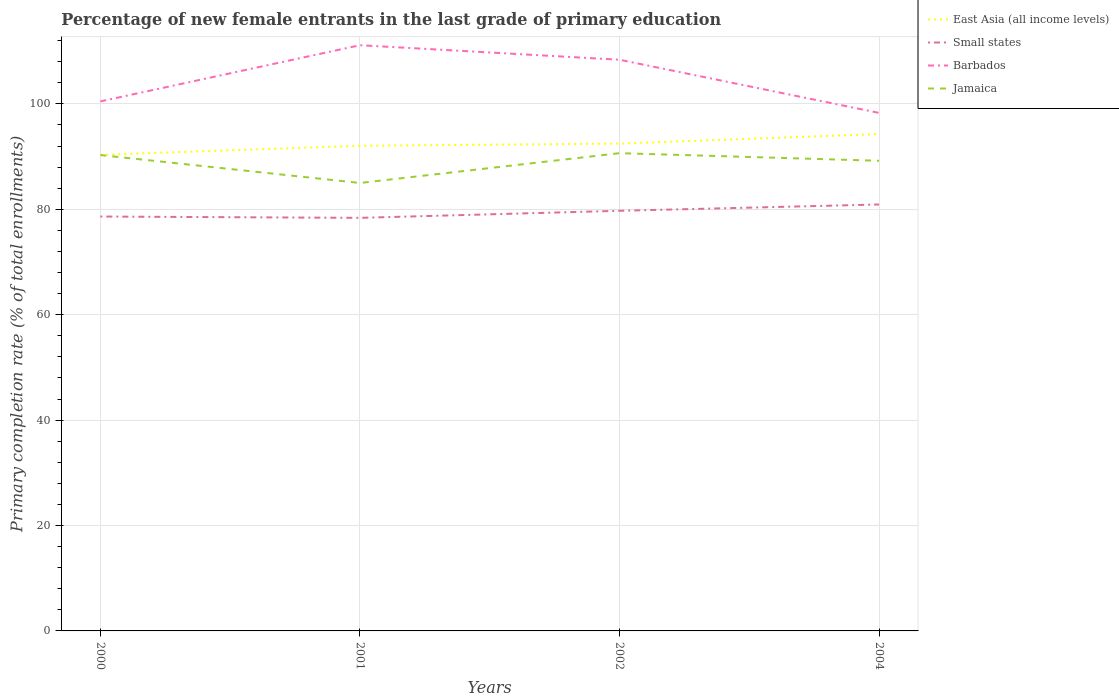How many different coloured lines are there?
Offer a very short reply. 4. Across all years, what is the maximum percentage of new female entrants in Jamaica?
Make the answer very short. 84.99. In which year was the percentage of new female entrants in Jamaica maximum?
Give a very brief answer. 2001. What is the total percentage of new female entrants in Jamaica in the graph?
Provide a short and direct response. -4.21. What is the difference between the highest and the second highest percentage of new female entrants in East Asia (all income levels)?
Give a very brief answer. 3.93. What is the difference between the highest and the lowest percentage of new female entrants in East Asia (all income levels)?
Ensure brevity in your answer.  2. What is the difference between two consecutive major ticks on the Y-axis?
Keep it short and to the point. 20. Are the values on the major ticks of Y-axis written in scientific E-notation?
Ensure brevity in your answer.  No. Does the graph contain any zero values?
Offer a terse response. No. Where does the legend appear in the graph?
Your answer should be compact. Top right. How are the legend labels stacked?
Your answer should be very brief. Vertical. What is the title of the graph?
Make the answer very short. Percentage of new female entrants in the last grade of primary education. What is the label or title of the Y-axis?
Ensure brevity in your answer.  Primary completion rate (% of total enrollments). What is the Primary completion rate (% of total enrollments) in East Asia (all income levels) in 2000?
Offer a terse response. 90.35. What is the Primary completion rate (% of total enrollments) in Small states in 2000?
Give a very brief answer. 78.63. What is the Primary completion rate (% of total enrollments) in Barbados in 2000?
Your response must be concise. 100.47. What is the Primary completion rate (% of total enrollments) of Jamaica in 2000?
Offer a very short reply. 90.29. What is the Primary completion rate (% of total enrollments) of East Asia (all income levels) in 2001?
Your answer should be very brief. 92.05. What is the Primary completion rate (% of total enrollments) of Small states in 2001?
Provide a short and direct response. 78.38. What is the Primary completion rate (% of total enrollments) in Barbados in 2001?
Your answer should be compact. 111.13. What is the Primary completion rate (% of total enrollments) in Jamaica in 2001?
Your answer should be compact. 84.99. What is the Primary completion rate (% of total enrollments) of East Asia (all income levels) in 2002?
Keep it short and to the point. 92.46. What is the Primary completion rate (% of total enrollments) of Small states in 2002?
Ensure brevity in your answer.  79.72. What is the Primary completion rate (% of total enrollments) of Barbados in 2002?
Make the answer very short. 108.38. What is the Primary completion rate (% of total enrollments) in Jamaica in 2002?
Your response must be concise. 90.65. What is the Primary completion rate (% of total enrollments) in East Asia (all income levels) in 2004?
Offer a very short reply. 94.28. What is the Primary completion rate (% of total enrollments) in Small states in 2004?
Keep it short and to the point. 80.91. What is the Primary completion rate (% of total enrollments) in Barbados in 2004?
Give a very brief answer. 98.29. What is the Primary completion rate (% of total enrollments) in Jamaica in 2004?
Provide a succinct answer. 89.21. Across all years, what is the maximum Primary completion rate (% of total enrollments) in East Asia (all income levels)?
Your answer should be compact. 94.28. Across all years, what is the maximum Primary completion rate (% of total enrollments) in Small states?
Give a very brief answer. 80.91. Across all years, what is the maximum Primary completion rate (% of total enrollments) in Barbados?
Your response must be concise. 111.13. Across all years, what is the maximum Primary completion rate (% of total enrollments) of Jamaica?
Your response must be concise. 90.65. Across all years, what is the minimum Primary completion rate (% of total enrollments) of East Asia (all income levels)?
Ensure brevity in your answer.  90.35. Across all years, what is the minimum Primary completion rate (% of total enrollments) of Small states?
Offer a very short reply. 78.38. Across all years, what is the minimum Primary completion rate (% of total enrollments) in Barbados?
Make the answer very short. 98.29. Across all years, what is the minimum Primary completion rate (% of total enrollments) in Jamaica?
Ensure brevity in your answer.  84.99. What is the total Primary completion rate (% of total enrollments) of East Asia (all income levels) in the graph?
Your response must be concise. 369.14. What is the total Primary completion rate (% of total enrollments) of Small states in the graph?
Provide a short and direct response. 317.63. What is the total Primary completion rate (% of total enrollments) of Barbados in the graph?
Offer a terse response. 418.27. What is the total Primary completion rate (% of total enrollments) of Jamaica in the graph?
Your answer should be compact. 355.14. What is the difference between the Primary completion rate (% of total enrollments) in East Asia (all income levels) in 2000 and that in 2001?
Your answer should be very brief. -1.71. What is the difference between the Primary completion rate (% of total enrollments) in Small states in 2000 and that in 2001?
Give a very brief answer. 0.25. What is the difference between the Primary completion rate (% of total enrollments) in Barbados in 2000 and that in 2001?
Your answer should be compact. -10.66. What is the difference between the Primary completion rate (% of total enrollments) of Jamaica in 2000 and that in 2001?
Your response must be concise. 5.3. What is the difference between the Primary completion rate (% of total enrollments) in East Asia (all income levels) in 2000 and that in 2002?
Your answer should be compact. -2.11. What is the difference between the Primary completion rate (% of total enrollments) in Small states in 2000 and that in 2002?
Offer a terse response. -1.09. What is the difference between the Primary completion rate (% of total enrollments) of Barbados in 2000 and that in 2002?
Your response must be concise. -7.91. What is the difference between the Primary completion rate (% of total enrollments) in Jamaica in 2000 and that in 2002?
Your answer should be very brief. -0.36. What is the difference between the Primary completion rate (% of total enrollments) of East Asia (all income levels) in 2000 and that in 2004?
Your answer should be compact. -3.93. What is the difference between the Primary completion rate (% of total enrollments) of Small states in 2000 and that in 2004?
Offer a very short reply. -2.28. What is the difference between the Primary completion rate (% of total enrollments) in Barbados in 2000 and that in 2004?
Offer a terse response. 2.18. What is the difference between the Primary completion rate (% of total enrollments) of Jamaica in 2000 and that in 2004?
Offer a very short reply. 1.09. What is the difference between the Primary completion rate (% of total enrollments) of East Asia (all income levels) in 2001 and that in 2002?
Make the answer very short. -0.41. What is the difference between the Primary completion rate (% of total enrollments) in Small states in 2001 and that in 2002?
Offer a very short reply. -1.34. What is the difference between the Primary completion rate (% of total enrollments) in Barbados in 2001 and that in 2002?
Provide a succinct answer. 2.76. What is the difference between the Primary completion rate (% of total enrollments) of Jamaica in 2001 and that in 2002?
Give a very brief answer. -5.65. What is the difference between the Primary completion rate (% of total enrollments) in East Asia (all income levels) in 2001 and that in 2004?
Provide a short and direct response. -2.23. What is the difference between the Primary completion rate (% of total enrollments) in Small states in 2001 and that in 2004?
Your response must be concise. -2.54. What is the difference between the Primary completion rate (% of total enrollments) of Barbados in 2001 and that in 2004?
Your response must be concise. 12.85. What is the difference between the Primary completion rate (% of total enrollments) of Jamaica in 2001 and that in 2004?
Your response must be concise. -4.21. What is the difference between the Primary completion rate (% of total enrollments) in East Asia (all income levels) in 2002 and that in 2004?
Your response must be concise. -1.82. What is the difference between the Primary completion rate (% of total enrollments) of Small states in 2002 and that in 2004?
Your answer should be compact. -1.19. What is the difference between the Primary completion rate (% of total enrollments) of Barbados in 2002 and that in 2004?
Your response must be concise. 10.09. What is the difference between the Primary completion rate (% of total enrollments) of Jamaica in 2002 and that in 2004?
Provide a short and direct response. 1.44. What is the difference between the Primary completion rate (% of total enrollments) of East Asia (all income levels) in 2000 and the Primary completion rate (% of total enrollments) of Small states in 2001?
Offer a terse response. 11.97. What is the difference between the Primary completion rate (% of total enrollments) of East Asia (all income levels) in 2000 and the Primary completion rate (% of total enrollments) of Barbados in 2001?
Ensure brevity in your answer.  -20.79. What is the difference between the Primary completion rate (% of total enrollments) in East Asia (all income levels) in 2000 and the Primary completion rate (% of total enrollments) in Jamaica in 2001?
Offer a terse response. 5.35. What is the difference between the Primary completion rate (% of total enrollments) in Small states in 2000 and the Primary completion rate (% of total enrollments) in Barbados in 2001?
Your response must be concise. -32.51. What is the difference between the Primary completion rate (% of total enrollments) of Small states in 2000 and the Primary completion rate (% of total enrollments) of Jamaica in 2001?
Offer a terse response. -6.37. What is the difference between the Primary completion rate (% of total enrollments) in Barbados in 2000 and the Primary completion rate (% of total enrollments) in Jamaica in 2001?
Your answer should be compact. 15.48. What is the difference between the Primary completion rate (% of total enrollments) in East Asia (all income levels) in 2000 and the Primary completion rate (% of total enrollments) in Small states in 2002?
Provide a short and direct response. 10.63. What is the difference between the Primary completion rate (% of total enrollments) of East Asia (all income levels) in 2000 and the Primary completion rate (% of total enrollments) of Barbados in 2002?
Your response must be concise. -18.03. What is the difference between the Primary completion rate (% of total enrollments) of East Asia (all income levels) in 2000 and the Primary completion rate (% of total enrollments) of Jamaica in 2002?
Make the answer very short. -0.3. What is the difference between the Primary completion rate (% of total enrollments) of Small states in 2000 and the Primary completion rate (% of total enrollments) of Barbados in 2002?
Keep it short and to the point. -29.75. What is the difference between the Primary completion rate (% of total enrollments) of Small states in 2000 and the Primary completion rate (% of total enrollments) of Jamaica in 2002?
Make the answer very short. -12.02. What is the difference between the Primary completion rate (% of total enrollments) in Barbados in 2000 and the Primary completion rate (% of total enrollments) in Jamaica in 2002?
Offer a very short reply. 9.82. What is the difference between the Primary completion rate (% of total enrollments) of East Asia (all income levels) in 2000 and the Primary completion rate (% of total enrollments) of Small states in 2004?
Offer a very short reply. 9.44. What is the difference between the Primary completion rate (% of total enrollments) in East Asia (all income levels) in 2000 and the Primary completion rate (% of total enrollments) in Barbados in 2004?
Provide a short and direct response. -7.94. What is the difference between the Primary completion rate (% of total enrollments) in East Asia (all income levels) in 2000 and the Primary completion rate (% of total enrollments) in Jamaica in 2004?
Give a very brief answer. 1.14. What is the difference between the Primary completion rate (% of total enrollments) of Small states in 2000 and the Primary completion rate (% of total enrollments) of Barbados in 2004?
Offer a very short reply. -19.66. What is the difference between the Primary completion rate (% of total enrollments) of Small states in 2000 and the Primary completion rate (% of total enrollments) of Jamaica in 2004?
Provide a succinct answer. -10.58. What is the difference between the Primary completion rate (% of total enrollments) in Barbados in 2000 and the Primary completion rate (% of total enrollments) in Jamaica in 2004?
Keep it short and to the point. 11.26. What is the difference between the Primary completion rate (% of total enrollments) in East Asia (all income levels) in 2001 and the Primary completion rate (% of total enrollments) in Small states in 2002?
Make the answer very short. 12.34. What is the difference between the Primary completion rate (% of total enrollments) of East Asia (all income levels) in 2001 and the Primary completion rate (% of total enrollments) of Barbados in 2002?
Make the answer very short. -16.32. What is the difference between the Primary completion rate (% of total enrollments) in East Asia (all income levels) in 2001 and the Primary completion rate (% of total enrollments) in Jamaica in 2002?
Your answer should be very brief. 1.4. What is the difference between the Primary completion rate (% of total enrollments) in Small states in 2001 and the Primary completion rate (% of total enrollments) in Barbados in 2002?
Your response must be concise. -30. What is the difference between the Primary completion rate (% of total enrollments) in Small states in 2001 and the Primary completion rate (% of total enrollments) in Jamaica in 2002?
Keep it short and to the point. -12.27. What is the difference between the Primary completion rate (% of total enrollments) in Barbados in 2001 and the Primary completion rate (% of total enrollments) in Jamaica in 2002?
Make the answer very short. 20.49. What is the difference between the Primary completion rate (% of total enrollments) of East Asia (all income levels) in 2001 and the Primary completion rate (% of total enrollments) of Small states in 2004?
Provide a succinct answer. 11.14. What is the difference between the Primary completion rate (% of total enrollments) in East Asia (all income levels) in 2001 and the Primary completion rate (% of total enrollments) in Barbados in 2004?
Offer a terse response. -6.24. What is the difference between the Primary completion rate (% of total enrollments) in East Asia (all income levels) in 2001 and the Primary completion rate (% of total enrollments) in Jamaica in 2004?
Give a very brief answer. 2.85. What is the difference between the Primary completion rate (% of total enrollments) of Small states in 2001 and the Primary completion rate (% of total enrollments) of Barbados in 2004?
Keep it short and to the point. -19.91. What is the difference between the Primary completion rate (% of total enrollments) of Small states in 2001 and the Primary completion rate (% of total enrollments) of Jamaica in 2004?
Offer a terse response. -10.83. What is the difference between the Primary completion rate (% of total enrollments) of Barbados in 2001 and the Primary completion rate (% of total enrollments) of Jamaica in 2004?
Your response must be concise. 21.93. What is the difference between the Primary completion rate (% of total enrollments) of East Asia (all income levels) in 2002 and the Primary completion rate (% of total enrollments) of Small states in 2004?
Provide a succinct answer. 11.55. What is the difference between the Primary completion rate (% of total enrollments) in East Asia (all income levels) in 2002 and the Primary completion rate (% of total enrollments) in Barbados in 2004?
Provide a succinct answer. -5.83. What is the difference between the Primary completion rate (% of total enrollments) in East Asia (all income levels) in 2002 and the Primary completion rate (% of total enrollments) in Jamaica in 2004?
Your answer should be very brief. 3.26. What is the difference between the Primary completion rate (% of total enrollments) of Small states in 2002 and the Primary completion rate (% of total enrollments) of Barbados in 2004?
Keep it short and to the point. -18.57. What is the difference between the Primary completion rate (% of total enrollments) of Small states in 2002 and the Primary completion rate (% of total enrollments) of Jamaica in 2004?
Provide a succinct answer. -9.49. What is the difference between the Primary completion rate (% of total enrollments) of Barbados in 2002 and the Primary completion rate (% of total enrollments) of Jamaica in 2004?
Provide a succinct answer. 19.17. What is the average Primary completion rate (% of total enrollments) of East Asia (all income levels) per year?
Ensure brevity in your answer.  92.29. What is the average Primary completion rate (% of total enrollments) of Small states per year?
Provide a succinct answer. 79.41. What is the average Primary completion rate (% of total enrollments) in Barbados per year?
Give a very brief answer. 104.57. What is the average Primary completion rate (% of total enrollments) in Jamaica per year?
Ensure brevity in your answer.  88.79. In the year 2000, what is the difference between the Primary completion rate (% of total enrollments) of East Asia (all income levels) and Primary completion rate (% of total enrollments) of Small states?
Your response must be concise. 11.72. In the year 2000, what is the difference between the Primary completion rate (% of total enrollments) in East Asia (all income levels) and Primary completion rate (% of total enrollments) in Barbados?
Offer a terse response. -10.12. In the year 2000, what is the difference between the Primary completion rate (% of total enrollments) of East Asia (all income levels) and Primary completion rate (% of total enrollments) of Jamaica?
Provide a succinct answer. 0.05. In the year 2000, what is the difference between the Primary completion rate (% of total enrollments) of Small states and Primary completion rate (% of total enrollments) of Barbados?
Provide a short and direct response. -21.84. In the year 2000, what is the difference between the Primary completion rate (% of total enrollments) of Small states and Primary completion rate (% of total enrollments) of Jamaica?
Provide a short and direct response. -11.67. In the year 2000, what is the difference between the Primary completion rate (% of total enrollments) of Barbados and Primary completion rate (% of total enrollments) of Jamaica?
Provide a short and direct response. 10.18. In the year 2001, what is the difference between the Primary completion rate (% of total enrollments) of East Asia (all income levels) and Primary completion rate (% of total enrollments) of Small states?
Provide a succinct answer. 13.68. In the year 2001, what is the difference between the Primary completion rate (% of total enrollments) in East Asia (all income levels) and Primary completion rate (% of total enrollments) in Barbados?
Your response must be concise. -19.08. In the year 2001, what is the difference between the Primary completion rate (% of total enrollments) of East Asia (all income levels) and Primary completion rate (% of total enrollments) of Jamaica?
Keep it short and to the point. 7.06. In the year 2001, what is the difference between the Primary completion rate (% of total enrollments) of Small states and Primary completion rate (% of total enrollments) of Barbados?
Ensure brevity in your answer.  -32.76. In the year 2001, what is the difference between the Primary completion rate (% of total enrollments) in Small states and Primary completion rate (% of total enrollments) in Jamaica?
Offer a terse response. -6.62. In the year 2001, what is the difference between the Primary completion rate (% of total enrollments) in Barbados and Primary completion rate (% of total enrollments) in Jamaica?
Provide a succinct answer. 26.14. In the year 2002, what is the difference between the Primary completion rate (% of total enrollments) of East Asia (all income levels) and Primary completion rate (% of total enrollments) of Small states?
Keep it short and to the point. 12.74. In the year 2002, what is the difference between the Primary completion rate (% of total enrollments) of East Asia (all income levels) and Primary completion rate (% of total enrollments) of Barbados?
Offer a terse response. -15.92. In the year 2002, what is the difference between the Primary completion rate (% of total enrollments) in East Asia (all income levels) and Primary completion rate (% of total enrollments) in Jamaica?
Your answer should be very brief. 1.81. In the year 2002, what is the difference between the Primary completion rate (% of total enrollments) of Small states and Primary completion rate (% of total enrollments) of Barbados?
Give a very brief answer. -28.66. In the year 2002, what is the difference between the Primary completion rate (% of total enrollments) of Small states and Primary completion rate (% of total enrollments) of Jamaica?
Make the answer very short. -10.93. In the year 2002, what is the difference between the Primary completion rate (% of total enrollments) of Barbados and Primary completion rate (% of total enrollments) of Jamaica?
Your response must be concise. 17.73. In the year 2004, what is the difference between the Primary completion rate (% of total enrollments) in East Asia (all income levels) and Primary completion rate (% of total enrollments) in Small states?
Offer a terse response. 13.37. In the year 2004, what is the difference between the Primary completion rate (% of total enrollments) of East Asia (all income levels) and Primary completion rate (% of total enrollments) of Barbados?
Offer a terse response. -4.01. In the year 2004, what is the difference between the Primary completion rate (% of total enrollments) of East Asia (all income levels) and Primary completion rate (% of total enrollments) of Jamaica?
Make the answer very short. 5.07. In the year 2004, what is the difference between the Primary completion rate (% of total enrollments) in Small states and Primary completion rate (% of total enrollments) in Barbados?
Make the answer very short. -17.38. In the year 2004, what is the difference between the Primary completion rate (% of total enrollments) in Small states and Primary completion rate (% of total enrollments) in Jamaica?
Provide a succinct answer. -8.29. In the year 2004, what is the difference between the Primary completion rate (% of total enrollments) of Barbados and Primary completion rate (% of total enrollments) of Jamaica?
Offer a terse response. 9.08. What is the ratio of the Primary completion rate (% of total enrollments) of East Asia (all income levels) in 2000 to that in 2001?
Offer a terse response. 0.98. What is the ratio of the Primary completion rate (% of total enrollments) of Barbados in 2000 to that in 2001?
Make the answer very short. 0.9. What is the ratio of the Primary completion rate (% of total enrollments) of Jamaica in 2000 to that in 2001?
Offer a very short reply. 1.06. What is the ratio of the Primary completion rate (% of total enrollments) in East Asia (all income levels) in 2000 to that in 2002?
Provide a succinct answer. 0.98. What is the ratio of the Primary completion rate (% of total enrollments) of Small states in 2000 to that in 2002?
Your answer should be compact. 0.99. What is the ratio of the Primary completion rate (% of total enrollments) of Barbados in 2000 to that in 2002?
Provide a succinct answer. 0.93. What is the ratio of the Primary completion rate (% of total enrollments) of Jamaica in 2000 to that in 2002?
Ensure brevity in your answer.  1. What is the ratio of the Primary completion rate (% of total enrollments) in Small states in 2000 to that in 2004?
Provide a succinct answer. 0.97. What is the ratio of the Primary completion rate (% of total enrollments) of Barbados in 2000 to that in 2004?
Your response must be concise. 1.02. What is the ratio of the Primary completion rate (% of total enrollments) in Jamaica in 2000 to that in 2004?
Your answer should be compact. 1.01. What is the ratio of the Primary completion rate (% of total enrollments) in Small states in 2001 to that in 2002?
Your answer should be compact. 0.98. What is the ratio of the Primary completion rate (% of total enrollments) in Barbados in 2001 to that in 2002?
Provide a short and direct response. 1.03. What is the ratio of the Primary completion rate (% of total enrollments) of Jamaica in 2001 to that in 2002?
Your response must be concise. 0.94. What is the ratio of the Primary completion rate (% of total enrollments) in East Asia (all income levels) in 2001 to that in 2004?
Provide a short and direct response. 0.98. What is the ratio of the Primary completion rate (% of total enrollments) of Small states in 2001 to that in 2004?
Provide a succinct answer. 0.97. What is the ratio of the Primary completion rate (% of total enrollments) in Barbados in 2001 to that in 2004?
Make the answer very short. 1.13. What is the ratio of the Primary completion rate (% of total enrollments) of Jamaica in 2001 to that in 2004?
Provide a succinct answer. 0.95. What is the ratio of the Primary completion rate (% of total enrollments) in East Asia (all income levels) in 2002 to that in 2004?
Your answer should be very brief. 0.98. What is the ratio of the Primary completion rate (% of total enrollments) of Small states in 2002 to that in 2004?
Ensure brevity in your answer.  0.99. What is the ratio of the Primary completion rate (% of total enrollments) in Barbados in 2002 to that in 2004?
Provide a short and direct response. 1.1. What is the ratio of the Primary completion rate (% of total enrollments) of Jamaica in 2002 to that in 2004?
Ensure brevity in your answer.  1.02. What is the difference between the highest and the second highest Primary completion rate (% of total enrollments) of East Asia (all income levels)?
Your answer should be very brief. 1.82. What is the difference between the highest and the second highest Primary completion rate (% of total enrollments) in Small states?
Make the answer very short. 1.19. What is the difference between the highest and the second highest Primary completion rate (% of total enrollments) of Barbados?
Offer a terse response. 2.76. What is the difference between the highest and the second highest Primary completion rate (% of total enrollments) in Jamaica?
Give a very brief answer. 0.36. What is the difference between the highest and the lowest Primary completion rate (% of total enrollments) of East Asia (all income levels)?
Offer a very short reply. 3.93. What is the difference between the highest and the lowest Primary completion rate (% of total enrollments) of Small states?
Your answer should be very brief. 2.54. What is the difference between the highest and the lowest Primary completion rate (% of total enrollments) of Barbados?
Your answer should be compact. 12.85. What is the difference between the highest and the lowest Primary completion rate (% of total enrollments) of Jamaica?
Keep it short and to the point. 5.65. 